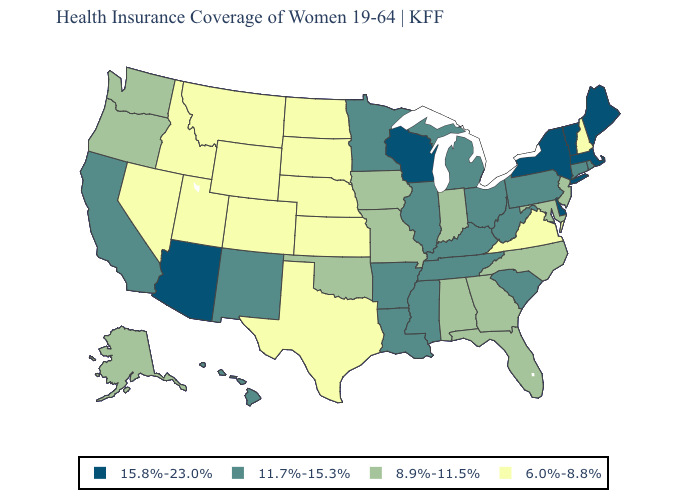Name the states that have a value in the range 11.7%-15.3%?
Concise answer only. Arkansas, California, Connecticut, Hawaii, Illinois, Kentucky, Louisiana, Michigan, Minnesota, Mississippi, New Mexico, Ohio, Pennsylvania, Rhode Island, South Carolina, Tennessee, West Virginia. Name the states that have a value in the range 8.9%-11.5%?
Short answer required. Alabama, Alaska, Florida, Georgia, Indiana, Iowa, Maryland, Missouri, New Jersey, North Carolina, Oklahoma, Oregon, Washington. Name the states that have a value in the range 15.8%-23.0%?
Answer briefly. Arizona, Delaware, Maine, Massachusetts, New York, Vermont, Wisconsin. Name the states that have a value in the range 15.8%-23.0%?
Short answer required. Arizona, Delaware, Maine, Massachusetts, New York, Vermont, Wisconsin. Name the states that have a value in the range 15.8%-23.0%?
Write a very short answer. Arizona, Delaware, Maine, Massachusetts, New York, Vermont, Wisconsin. Among the states that border North Dakota , which have the lowest value?
Keep it brief. Montana, South Dakota. Does New Hampshire have the lowest value in the Northeast?
Be succinct. Yes. What is the lowest value in the West?
Quick response, please. 6.0%-8.8%. Name the states that have a value in the range 6.0%-8.8%?
Write a very short answer. Colorado, Idaho, Kansas, Montana, Nebraska, Nevada, New Hampshire, North Dakota, South Dakota, Texas, Utah, Virginia, Wyoming. Which states hav the highest value in the MidWest?
Write a very short answer. Wisconsin. Does Oklahoma have the lowest value in the South?
Write a very short answer. No. How many symbols are there in the legend?
Short answer required. 4. Does California have the highest value in the USA?
Write a very short answer. No. Which states have the highest value in the USA?
Give a very brief answer. Arizona, Delaware, Maine, Massachusetts, New York, Vermont, Wisconsin. Name the states that have a value in the range 6.0%-8.8%?
Keep it brief. Colorado, Idaho, Kansas, Montana, Nebraska, Nevada, New Hampshire, North Dakota, South Dakota, Texas, Utah, Virginia, Wyoming. 